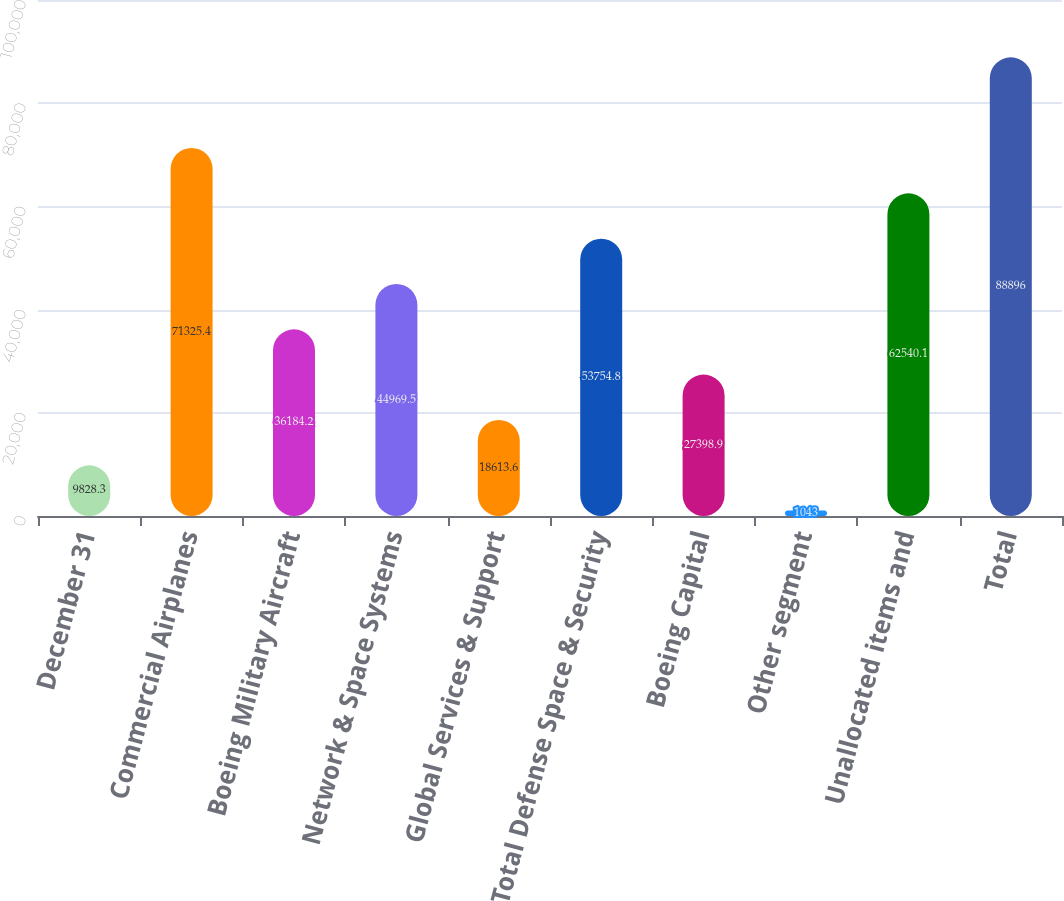Convert chart to OTSL. <chart><loc_0><loc_0><loc_500><loc_500><bar_chart><fcel>December 31<fcel>Commercial Airplanes<fcel>Boeing Military Aircraft<fcel>Network & Space Systems<fcel>Global Services & Support<fcel>Total Defense Space & Security<fcel>Boeing Capital<fcel>Other segment<fcel>Unallocated items and<fcel>Total<nl><fcel>9828.3<fcel>71325.4<fcel>36184.2<fcel>44969.5<fcel>18613.6<fcel>53754.8<fcel>27398.9<fcel>1043<fcel>62540.1<fcel>88896<nl></chart> 